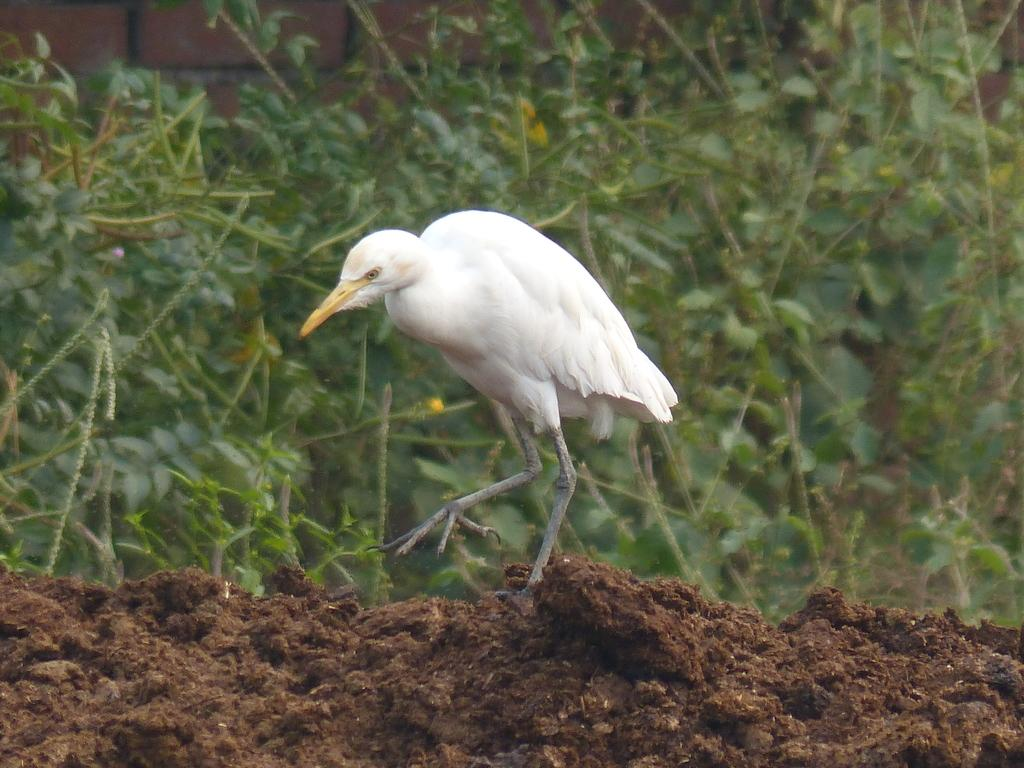What is the main element in the picture? There is mud in the picture. What type of animal can be seen in the picture? There is a white bird in the picture. What is the bird doing in the picture? The bird is walking. What can be seen in the background of the picture? There are plants and a wall with bricks visible in the background. What type of grape is the bird holding in its beak in the picture? There is no grape present in the picture; the bird is walking in the mud. Is the bird wearing a dress in the picture? The bird is not wearing a dress in the picture; it is a bird, and birds do not wear clothing. 